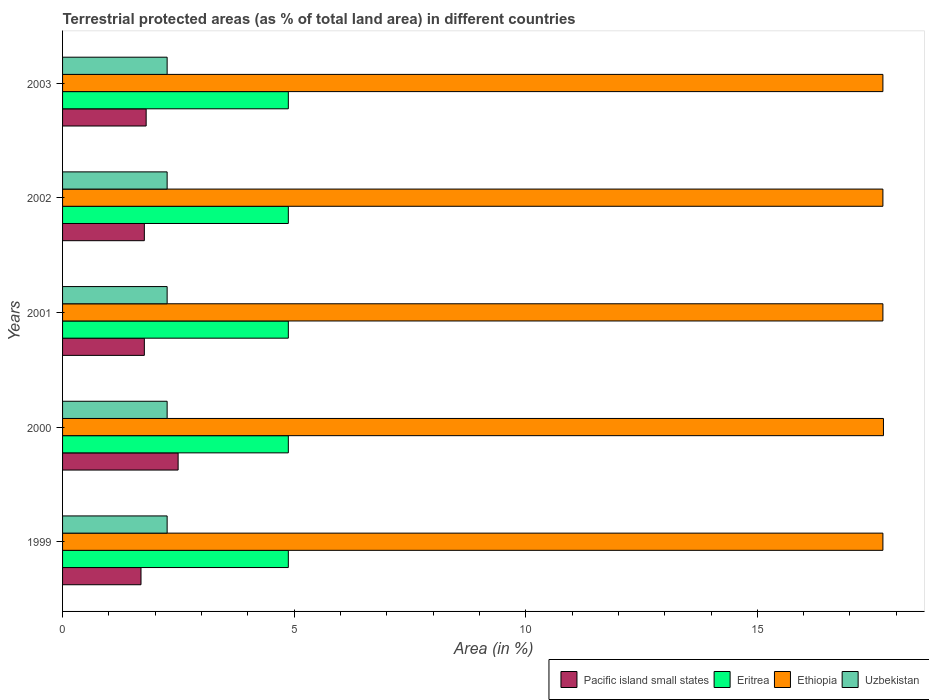How many different coloured bars are there?
Keep it short and to the point. 4. How many groups of bars are there?
Give a very brief answer. 5. How many bars are there on the 4th tick from the bottom?
Your answer should be compact. 4. In how many cases, is the number of bars for a given year not equal to the number of legend labels?
Your answer should be compact. 0. What is the percentage of terrestrial protected land in Uzbekistan in 2000?
Give a very brief answer. 2.26. Across all years, what is the maximum percentage of terrestrial protected land in Uzbekistan?
Give a very brief answer. 2.26. Across all years, what is the minimum percentage of terrestrial protected land in Uzbekistan?
Make the answer very short. 2.26. In which year was the percentage of terrestrial protected land in Pacific island small states maximum?
Your answer should be compact. 2000. In which year was the percentage of terrestrial protected land in Ethiopia minimum?
Ensure brevity in your answer.  1999. What is the total percentage of terrestrial protected land in Ethiopia in the graph?
Offer a terse response. 88.57. What is the difference between the percentage of terrestrial protected land in Uzbekistan in 1999 and that in 2001?
Ensure brevity in your answer.  0. What is the difference between the percentage of terrestrial protected land in Uzbekistan in 2001 and the percentage of terrestrial protected land in Eritrea in 2002?
Keep it short and to the point. -2.62. What is the average percentage of terrestrial protected land in Pacific island small states per year?
Provide a short and direct response. 1.9. In the year 2000, what is the difference between the percentage of terrestrial protected land in Pacific island small states and percentage of terrestrial protected land in Eritrea?
Make the answer very short. -2.38. In how many years, is the percentage of terrestrial protected land in Ethiopia greater than 10 %?
Keep it short and to the point. 5. What is the ratio of the percentage of terrestrial protected land in Eritrea in 1999 to that in 2000?
Ensure brevity in your answer.  1. Is the percentage of terrestrial protected land in Ethiopia in 1999 less than that in 2003?
Keep it short and to the point. No. What is the difference between the highest and the second highest percentage of terrestrial protected land in Pacific island small states?
Your response must be concise. 0.69. What is the difference between the highest and the lowest percentage of terrestrial protected land in Pacific island small states?
Ensure brevity in your answer.  0.8. Is it the case that in every year, the sum of the percentage of terrestrial protected land in Uzbekistan and percentage of terrestrial protected land in Ethiopia is greater than the sum of percentage of terrestrial protected land in Eritrea and percentage of terrestrial protected land in Pacific island small states?
Ensure brevity in your answer.  Yes. What does the 3rd bar from the top in 2002 represents?
Your answer should be very brief. Eritrea. What does the 3rd bar from the bottom in 2001 represents?
Your answer should be compact. Ethiopia. Is it the case that in every year, the sum of the percentage of terrestrial protected land in Eritrea and percentage of terrestrial protected land in Pacific island small states is greater than the percentage of terrestrial protected land in Ethiopia?
Make the answer very short. No. How many years are there in the graph?
Give a very brief answer. 5. Are the values on the major ticks of X-axis written in scientific E-notation?
Keep it short and to the point. No. Does the graph contain grids?
Offer a very short reply. No. Where does the legend appear in the graph?
Keep it short and to the point. Bottom right. What is the title of the graph?
Ensure brevity in your answer.  Terrestrial protected areas (as % of total land area) in different countries. What is the label or title of the X-axis?
Give a very brief answer. Area (in %). What is the Area (in %) in Pacific island small states in 1999?
Provide a short and direct response. 1.69. What is the Area (in %) of Eritrea in 1999?
Provide a short and direct response. 4.87. What is the Area (in %) in Ethiopia in 1999?
Your response must be concise. 17.71. What is the Area (in %) in Uzbekistan in 1999?
Provide a short and direct response. 2.26. What is the Area (in %) in Pacific island small states in 2000?
Your answer should be very brief. 2.49. What is the Area (in %) of Eritrea in 2000?
Provide a short and direct response. 4.87. What is the Area (in %) of Ethiopia in 2000?
Give a very brief answer. 17.72. What is the Area (in %) of Uzbekistan in 2000?
Make the answer very short. 2.26. What is the Area (in %) of Pacific island small states in 2001?
Provide a short and direct response. 1.77. What is the Area (in %) in Eritrea in 2001?
Give a very brief answer. 4.87. What is the Area (in %) of Ethiopia in 2001?
Your response must be concise. 17.71. What is the Area (in %) of Uzbekistan in 2001?
Your response must be concise. 2.26. What is the Area (in %) in Pacific island small states in 2002?
Make the answer very short. 1.77. What is the Area (in %) of Eritrea in 2002?
Ensure brevity in your answer.  4.87. What is the Area (in %) in Ethiopia in 2002?
Ensure brevity in your answer.  17.71. What is the Area (in %) of Uzbekistan in 2002?
Provide a succinct answer. 2.26. What is the Area (in %) in Pacific island small states in 2003?
Keep it short and to the point. 1.8. What is the Area (in %) in Eritrea in 2003?
Offer a terse response. 4.87. What is the Area (in %) in Ethiopia in 2003?
Your answer should be very brief. 17.71. What is the Area (in %) in Uzbekistan in 2003?
Ensure brevity in your answer.  2.26. Across all years, what is the maximum Area (in %) of Pacific island small states?
Offer a terse response. 2.49. Across all years, what is the maximum Area (in %) in Eritrea?
Provide a short and direct response. 4.87. Across all years, what is the maximum Area (in %) in Ethiopia?
Keep it short and to the point. 17.72. Across all years, what is the maximum Area (in %) of Uzbekistan?
Your response must be concise. 2.26. Across all years, what is the minimum Area (in %) of Pacific island small states?
Ensure brevity in your answer.  1.69. Across all years, what is the minimum Area (in %) in Eritrea?
Your response must be concise. 4.87. Across all years, what is the minimum Area (in %) of Ethiopia?
Your answer should be very brief. 17.71. Across all years, what is the minimum Area (in %) in Uzbekistan?
Make the answer very short. 2.26. What is the total Area (in %) in Pacific island small states in the graph?
Make the answer very short. 9.52. What is the total Area (in %) in Eritrea in the graph?
Offer a terse response. 24.37. What is the total Area (in %) of Ethiopia in the graph?
Give a very brief answer. 88.57. What is the total Area (in %) in Uzbekistan in the graph?
Make the answer very short. 11.29. What is the difference between the Area (in %) of Pacific island small states in 1999 and that in 2000?
Your answer should be compact. -0.8. What is the difference between the Area (in %) of Ethiopia in 1999 and that in 2000?
Ensure brevity in your answer.  -0.01. What is the difference between the Area (in %) in Pacific island small states in 1999 and that in 2001?
Your answer should be very brief. -0.07. What is the difference between the Area (in %) in Uzbekistan in 1999 and that in 2001?
Give a very brief answer. 0. What is the difference between the Area (in %) of Pacific island small states in 1999 and that in 2002?
Keep it short and to the point. -0.07. What is the difference between the Area (in %) of Pacific island small states in 1999 and that in 2003?
Your answer should be compact. -0.11. What is the difference between the Area (in %) of Uzbekistan in 1999 and that in 2003?
Give a very brief answer. 0. What is the difference between the Area (in %) of Pacific island small states in 2000 and that in 2001?
Your response must be concise. 0.73. What is the difference between the Area (in %) in Ethiopia in 2000 and that in 2001?
Provide a succinct answer. 0.01. What is the difference between the Area (in %) of Uzbekistan in 2000 and that in 2001?
Your response must be concise. 0. What is the difference between the Area (in %) in Pacific island small states in 2000 and that in 2002?
Provide a succinct answer. 0.73. What is the difference between the Area (in %) of Eritrea in 2000 and that in 2002?
Your answer should be very brief. 0. What is the difference between the Area (in %) in Ethiopia in 2000 and that in 2002?
Your answer should be compact. 0.01. What is the difference between the Area (in %) of Pacific island small states in 2000 and that in 2003?
Keep it short and to the point. 0.69. What is the difference between the Area (in %) of Ethiopia in 2000 and that in 2003?
Your response must be concise. 0.01. What is the difference between the Area (in %) of Pacific island small states in 2001 and that in 2002?
Provide a succinct answer. 0. What is the difference between the Area (in %) in Eritrea in 2001 and that in 2002?
Your response must be concise. 0. What is the difference between the Area (in %) in Pacific island small states in 2001 and that in 2003?
Keep it short and to the point. -0.04. What is the difference between the Area (in %) in Eritrea in 2001 and that in 2003?
Your answer should be very brief. 0. What is the difference between the Area (in %) in Uzbekistan in 2001 and that in 2003?
Give a very brief answer. 0. What is the difference between the Area (in %) of Pacific island small states in 2002 and that in 2003?
Ensure brevity in your answer.  -0.04. What is the difference between the Area (in %) of Uzbekistan in 2002 and that in 2003?
Keep it short and to the point. 0. What is the difference between the Area (in %) of Pacific island small states in 1999 and the Area (in %) of Eritrea in 2000?
Provide a short and direct response. -3.18. What is the difference between the Area (in %) of Pacific island small states in 1999 and the Area (in %) of Ethiopia in 2000?
Make the answer very short. -16.03. What is the difference between the Area (in %) in Pacific island small states in 1999 and the Area (in %) in Uzbekistan in 2000?
Provide a succinct answer. -0.56. What is the difference between the Area (in %) in Eritrea in 1999 and the Area (in %) in Ethiopia in 2000?
Make the answer very short. -12.85. What is the difference between the Area (in %) in Eritrea in 1999 and the Area (in %) in Uzbekistan in 2000?
Your answer should be very brief. 2.62. What is the difference between the Area (in %) in Ethiopia in 1999 and the Area (in %) in Uzbekistan in 2000?
Provide a succinct answer. 15.45. What is the difference between the Area (in %) in Pacific island small states in 1999 and the Area (in %) in Eritrea in 2001?
Make the answer very short. -3.18. What is the difference between the Area (in %) of Pacific island small states in 1999 and the Area (in %) of Ethiopia in 2001?
Provide a succinct answer. -16.02. What is the difference between the Area (in %) of Pacific island small states in 1999 and the Area (in %) of Uzbekistan in 2001?
Ensure brevity in your answer.  -0.56. What is the difference between the Area (in %) of Eritrea in 1999 and the Area (in %) of Ethiopia in 2001?
Your answer should be compact. -12.84. What is the difference between the Area (in %) of Eritrea in 1999 and the Area (in %) of Uzbekistan in 2001?
Offer a very short reply. 2.62. What is the difference between the Area (in %) in Ethiopia in 1999 and the Area (in %) in Uzbekistan in 2001?
Give a very brief answer. 15.45. What is the difference between the Area (in %) in Pacific island small states in 1999 and the Area (in %) in Eritrea in 2002?
Your answer should be compact. -3.18. What is the difference between the Area (in %) in Pacific island small states in 1999 and the Area (in %) in Ethiopia in 2002?
Give a very brief answer. -16.02. What is the difference between the Area (in %) of Pacific island small states in 1999 and the Area (in %) of Uzbekistan in 2002?
Keep it short and to the point. -0.56. What is the difference between the Area (in %) in Eritrea in 1999 and the Area (in %) in Ethiopia in 2002?
Make the answer very short. -12.84. What is the difference between the Area (in %) in Eritrea in 1999 and the Area (in %) in Uzbekistan in 2002?
Your answer should be compact. 2.62. What is the difference between the Area (in %) of Ethiopia in 1999 and the Area (in %) of Uzbekistan in 2002?
Your answer should be compact. 15.45. What is the difference between the Area (in %) of Pacific island small states in 1999 and the Area (in %) of Eritrea in 2003?
Give a very brief answer. -3.18. What is the difference between the Area (in %) of Pacific island small states in 1999 and the Area (in %) of Ethiopia in 2003?
Offer a terse response. -16.02. What is the difference between the Area (in %) in Pacific island small states in 1999 and the Area (in %) in Uzbekistan in 2003?
Offer a terse response. -0.56. What is the difference between the Area (in %) in Eritrea in 1999 and the Area (in %) in Ethiopia in 2003?
Offer a terse response. -12.84. What is the difference between the Area (in %) in Eritrea in 1999 and the Area (in %) in Uzbekistan in 2003?
Provide a succinct answer. 2.62. What is the difference between the Area (in %) of Ethiopia in 1999 and the Area (in %) of Uzbekistan in 2003?
Ensure brevity in your answer.  15.45. What is the difference between the Area (in %) of Pacific island small states in 2000 and the Area (in %) of Eritrea in 2001?
Provide a short and direct response. -2.38. What is the difference between the Area (in %) of Pacific island small states in 2000 and the Area (in %) of Ethiopia in 2001?
Provide a succinct answer. -15.22. What is the difference between the Area (in %) of Pacific island small states in 2000 and the Area (in %) of Uzbekistan in 2001?
Ensure brevity in your answer.  0.24. What is the difference between the Area (in %) in Eritrea in 2000 and the Area (in %) in Ethiopia in 2001?
Your response must be concise. -12.84. What is the difference between the Area (in %) in Eritrea in 2000 and the Area (in %) in Uzbekistan in 2001?
Keep it short and to the point. 2.62. What is the difference between the Area (in %) in Ethiopia in 2000 and the Area (in %) in Uzbekistan in 2001?
Provide a succinct answer. 15.46. What is the difference between the Area (in %) of Pacific island small states in 2000 and the Area (in %) of Eritrea in 2002?
Provide a succinct answer. -2.38. What is the difference between the Area (in %) in Pacific island small states in 2000 and the Area (in %) in Ethiopia in 2002?
Keep it short and to the point. -15.22. What is the difference between the Area (in %) in Pacific island small states in 2000 and the Area (in %) in Uzbekistan in 2002?
Ensure brevity in your answer.  0.24. What is the difference between the Area (in %) of Eritrea in 2000 and the Area (in %) of Ethiopia in 2002?
Offer a very short reply. -12.84. What is the difference between the Area (in %) in Eritrea in 2000 and the Area (in %) in Uzbekistan in 2002?
Ensure brevity in your answer.  2.62. What is the difference between the Area (in %) of Ethiopia in 2000 and the Area (in %) of Uzbekistan in 2002?
Provide a short and direct response. 15.46. What is the difference between the Area (in %) of Pacific island small states in 2000 and the Area (in %) of Eritrea in 2003?
Ensure brevity in your answer.  -2.38. What is the difference between the Area (in %) in Pacific island small states in 2000 and the Area (in %) in Ethiopia in 2003?
Provide a succinct answer. -15.22. What is the difference between the Area (in %) of Pacific island small states in 2000 and the Area (in %) of Uzbekistan in 2003?
Ensure brevity in your answer.  0.24. What is the difference between the Area (in %) in Eritrea in 2000 and the Area (in %) in Ethiopia in 2003?
Give a very brief answer. -12.84. What is the difference between the Area (in %) of Eritrea in 2000 and the Area (in %) of Uzbekistan in 2003?
Provide a short and direct response. 2.62. What is the difference between the Area (in %) in Ethiopia in 2000 and the Area (in %) in Uzbekistan in 2003?
Ensure brevity in your answer.  15.46. What is the difference between the Area (in %) of Pacific island small states in 2001 and the Area (in %) of Eritrea in 2002?
Provide a succinct answer. -3.11. What is the difference between the Area (in %) in Pacific island small states in 2001 and the Area (in %) in Ethiopia in 2002?
Keep it short and to the point. -15.95. What is the difference between the Area (in %) in Pacific island small states in 2001 and the Area (in %) in Uzbekistan in 2002?
Give a very brief answer. -0.49. What is the difference between the Area (in %) of Eritrea in 2001 and the Area (in %) of Ethiopia in 2002?
Your response must be concise. -12.84. What is the difference between the Area (in %) of Eritrea in 2001 and the Area (in %) of Uzbekistan in 2002?
Keep it short and to the point. 2.62. What is the difference between the Area (in %) of Ethiopia in 2001 and the Area (in %) of Uzbekistan in 2002?
Provide a short and direct response. 15.45. What is the difference between the Area (in %) of Pacific island small states in 2001 and the Area (in %) of Eritrea in 2003?
Ensure brevity in your answer.  -3.11. What is the difference between the Area (in %) in Pacific island small states in 2001 and the Area (in %) in Ethiopia in 2003?
Your answer should be very brief. -15.95. What is the difference between the Area (in %) of Pacific island small states in 2001 and the Area (in %) of Uzbekistan in 2003?
Offer a very short reply. -0.49. What is the difference between the Area (in %) of Eritrea in 2001 and the Area (in %) of Ethiopia in 2003?
Your answer should be compact. -12.84. What is the difference between the Area (in %) of Eritrea in 2001 and the Area (in %) of Uzbekistan in 2003?
Ensure brevity in your answer.  2.62. What is the difference between the Area (in %) of Ethiopia in 2001 and the Area (in %) of Uzbekistan in 2003?
Provide a short and direct response. 15.45. What is the difference between the Area (in %) in Pacific island small states in 2002 and the Area (in %) in Eritrea in 2003?
Offer a very short reply. -3.11. What is the difference between the Area (in %) of Pacific island small states in 2002 and the Area (in %) of Ethiopia in 2003?
Give a very brief answer. -15.95. What is the difference between the Area (in %) of Pacific island small states in 2002 and the Area (in %) of Uzbekistan in 2003?
Your response must be concise. -0.49. What is the difference between the Area (in %) in Eritrea in 2002 and the Area (in %) in Ethiopia in 2003?
Ensure brevity in your answer.  -12.84. What is the difference between the Area (in %) of Eritrea in 2002 and the Area (in %) of Uzbekistan in 2003?
Your answer should be very brief. 2.62. What is the difference between the Area (in %) in Ethiopia in 2002 and the Area (in %) in Uzbekistan in 2003?
Offer a terse response. 15.45. What is the average Area (in %) of Pacific island small states per year?
Your answer should be compact. 1.9. What is the average Area (in %) of Eritrea per year?
Provide a succinct answer. 4.87. What is the average Area (in %) in Ethiopia per year?
Give a very brief answer. 17.71. What is the average Area (in %) of Uzbekistan per year?
Offer a terse response. 2.26. In the year 1999, what is the difference between the Area (in %) in Pacific island small states and Area (in %) in Eritrea?
Ensure brevity in your answer.  -3.18. In the year 1999, what is the difference between the Area (in %) of Pacific island small states and Area (in %) of Ethiopia?
Your answer should be very brief. -16.02. In the year 1999, what is the difference between the Area (in %) of Pacific island small states and Area (in %) of Uzbekistan?
Your answer should be compact. -0.56. In the year 1999, what is the difference between the Area (in %) of Eritrea and Area (in %) of Ethiopia?
Provide a succinct answer. -12.84. In the year 1999, what is the difference between the Area (in %) of Eritrea and Area (in %) of Uzbekistan?
Your response must be concise. 2.62. In the year 1999, what is the difference between the Area (in %) in Ethiopia and Area (in %) in Uzbekistan?
Offer a terse response. 15.45. In the year 2000, what is the difference between the Area (in %) of Pacific island small states and Area (in %) of Eritrea?
Your response must be concise. -2.38. In the year 2000, what is the difference between the Area (in %) of Pacific island small states and Area (in %) of Ethiopia?
Make the answer very short. -15.23. In the year 2000, what is the difference between the Area (in %) of Pacific island small states and Area (in %) of Uzbekistan?
Ensure brevity in your answer.  0.24. In the year 2000, what is the difference between the Area (in %) in Eritrea and Area (in %) in Ethiopia?
Ensure brevity in your answer.  -12.85. In the year 2000, what is the difference between the Area (in %) of Eritrea and Area (in %) of Uzbekistan?
Offer a very short reply. 2.62. In the year 2000, what is the difference between the Area (in %) of Ethiopia and Area (in %) of Uzbekistan?
Your answer should be compact. 15.46. In the year 2001, what is the difference between the Area (in %) of Pacific island small states and Area (in %) of Eritrea?
Your response must be concise. -3.11. In the year 2001, what is the difference between the Area (in %) of Pacific island small states and Area (in %) of Ethiopia?
Your response must be concise. -15.95. In the year 2001, what is the difference between the Area (in %) in Pacific island small states and Area (in %) in Uzbekistan?
Offer a terse response. -0.49. In the year 2001, what is the difference between the Area (in %) in Eritrea and Area (in %) in Ethiopia?
Provide a short and direct response. -12.84. In the year 2001, what is the difference between the Area (in %) of Eritrea and Area (in %) of Uzbekistan?
Your response must be concise. 2.62. In the year 2001, what is the difference between the Area (in %) in Ethiopia and Area (in %) in Uzbekistan?
Your answer should be very brief. 15.45. In the year 2002, what is the difference between the Area (in %) of Pacific island small states and Area (in %) of Eritrea?
Your response must be concise. -3.11. In the year 2002, what is the difference between the Area (in %) of Pacific island small states and Area (in %) of Ethiopia?
Provide a short and direct response. -15.95. In the year 2002, what is the difference between the Area (in %) in Pacific island small states and Area (in %) in Uzbekistan?
Ensure brevity in your answer.  -0.49. In the year 2002, what is the difference between the Area (in %) of Eritrea and Area (in %) of Ethiopia?
Ensure brevity in your answer.  -12.84. In the year 2002, what is the difference between the Area (in %) of Eritrea and Area (in %) of Uzbekistan?
Provide a succinct answer. 2.62. In the year 2002, what is the difference between the Area (in %) of Ethiopia and Area (in %) of Uzbekistan?
Give a very brief answer. 15.45. In the year 2003, what is the difference between the Area (in %) of Pacific island small states and Area (in %) of Eritrea?
Your answer should be very brief. -3.07. In the year 2003, what is the difference between the Area (in %) of Pacific island small states and Area (in %) of Ethiopia?
Your answer should be compact. -15.91. In the year 2003, what is the difference between the Area (in %) of Pacific island small states and Area (in %) of Uzbekistan?
Your answer should be very brief. -0.45. In the year 2003, what is the difference between the Area (in %) in Eritrea and Area (in %) in Ethiopia?
Give a very brief answer. -12.84. In the year 2003, what is the difference between the Area (in %) of Eritrea and Area (in %) of Uzbekistan?
Provide a short and direct response. 2.62. In the year 2003, what is the difference between the Area (in %) in Ethiopia and Area (in %) in Uzbekistan?
Your answer should be very brief. 15.45. What is the ratio of the Area (in %) of Pacific island small states in 1999 to that in 2000?
Offer a very short reply. 0.68. What is the ratio of the Area (in %) in Ethiopia in 1999 to that in 2000?
Offer a terse response. 1. What is the ratio of the Area (in %) of Pacific island small states in 1999 to that in 2001?
Give a very brief answer. 0.96. What is the ratio of the Area (in %) of Eritrea in 1999 to that in 2001?
Your answer should be compact. 1. What is the ratio of the Area (in %) of Ethiopia in 1999 to that in 2001?
Keep it short and to the point. 1. What is the ratio of the Area (in %) in Uzbekistan in 1999 to that in 2001?
Offer a very short reply. 1. What is the ratio of the Area (in %) in Pacific island small states in 1999 to that in 2002?
Make the answer very short. 0.96. What is the ratio of the Area (in %) in Ethiopia in 1999 to that in 2002?
Your answer should be compact. 1. What is the ratio of the Area (in %) of Pacific island small states in 1999 to that in 2003?
Your answer should be compact. 0.94. What is the ratio of the Area (in %) of Eritrea in 1999 to that in 2003?
Provide a succinct answer. 1. What is the ratio of the Area (in %) in Ethiopia in 1999 to that in 2003?
Your response must be concise. 1. What is the ratio of the Area (in %) in Pacific island small states in 2000 to that in 2001?
Provide a succinct answer. 1.41. What is the ratio of the Area (in %) of Eritrea in 2000 to that in 2001?
Offer a terse response. 1. What is the ratio of the Area (in %) in Uzbekistan in 2000 to that in 2001?
Offer a very short reply. 1. What is the ratio of the Area (in %) of Pacific island small states in 2000 to that in 2002?
Your answer should be compact. 1.41. What is the ratio of the Area (in %) in Ethiopia in 2000 to that in 2002?
Ensure brevity in your answer.  1. What is the ratio of the Area (in %) of Uzbekistan in 2000 to that in 2002?
Your response must be concise. 1. What is the ratio of the Area (in %) of Pacific island small states in 2000 to that in 2003?
Provide a succinct answer. 1.38. What is the ratio of the Area (in %) in Eritrea in 2000 to that in 2003?
Provide a succinct answer. 1. What is the ratio of the Area (in %) of Ethiopia in 2000 to that in 2003?
Make the answer very short. 1. What is the ratio of the Area (in %) of Uzbekistan in 2001 to that in 2002?
Ensure brevity in your answer.  1. What is the ratio of the Area (in %) in Pacific island small states in 2001 to that in 2003?
Offer a very short reply. 0.98. What is the ratio of the Area (in %) in Eritrea in 2001 to that in 2003?
Provide a succinct answer. 1. What is the ratio of the Area (in %) in Pacific island small states in 2002 to that in 2003?
Provide a succinct answer. 0.98. What is the ratio of the Area (in %) in Ethiopia in 2002 to that in 2003?
Make the answer very short. 1. What is the ratio of the Area (in %) in Uzbekistan in 2002 to that in 2003?
Offer a terse response. 1. What is the difference between the highest and the second highest Area (in %) of Pacific island small states?
Offer a very short reply. 0.69. What is the difference between the highest and the second highest Area (in %) of Eritrea?
Offer a terse response. 0. What is the difference between the highest and the second highest Area (in %) of Ethiopia?
Your answer should be very brief. 0.01. What is the difference between the highest and the second highest Area (in %) in Uzbekistan?
Your answer should be compact. 0. What is the difference between the highest and the lowest Area (in %) of Pacific island small states?
Offer a terse response. 0.8. What is the difference between the highest and the lowest Area (in %) in Ethiopia?
Give a very brief answer. 0.01. What is the difference between the highest and the lowest Area (in %) of Uzbekistan?
Offer a very short reply. 0. 